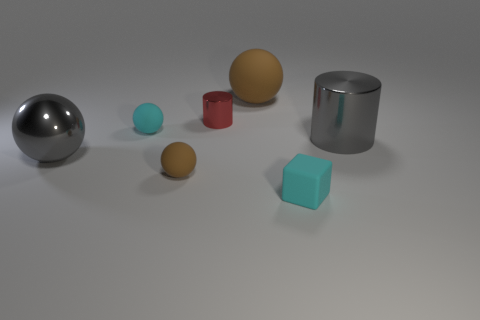Are any big cyan matte spheres visible?
Ensure brevity in your answer.  No. Do the small shiny object and the big matte object have the same shape?
Give a very brief answer. No. The rubber ball that is the same color as the small rubber cube is what size?
Your answer should be compact. Small. How many metal balls are behind the large gray cylinder on the right side of the small brown rubber thing?
Your response must be concise. 0. How many gray objects are to the left of the tiny cyan matte cube and behind the metal sphere?
Make the answer very short. 0. How many objects are purple cylinders or large gray things that are left of the large metal cylinder?
Offer a terse response. 1. What is the size of the gray sphere that is made of the same material as the tiny red object?
Provide a short and direct response. Large. There is a tiny cyan rubber thing behind the gray shiny thing to the right of the tiny red metal thing; what shape is it?
Provide a short and direct response. Sphere. What number of cyan objects are tiny blocks or tiny cylinders?
Provide a succinct answer. 1. There is a cyan thing that is in front of the gray metal thing right of the tiny cyan rubber cube; is there a brown object to the right of it?
Give a very brief answer. No. 